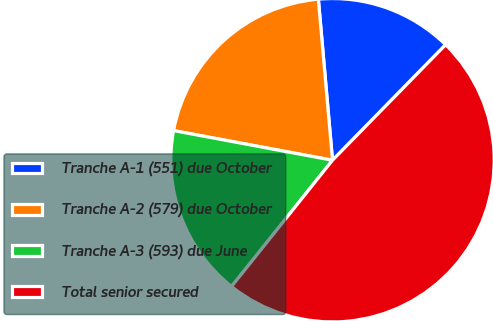<chart> <loc_0><loc_0><loc_500><loc_500><pie_chart><fcel>Tranche A-1 (551) due October<fcel>Tranche A-2 (579) due October<fcel>Tranche A-3 (593) due June<fcel>Total senior secured<nl><fcel>13.73%<fcel>20.67%<fcel>17.2%<fcel>48.4%<nl></chart> 